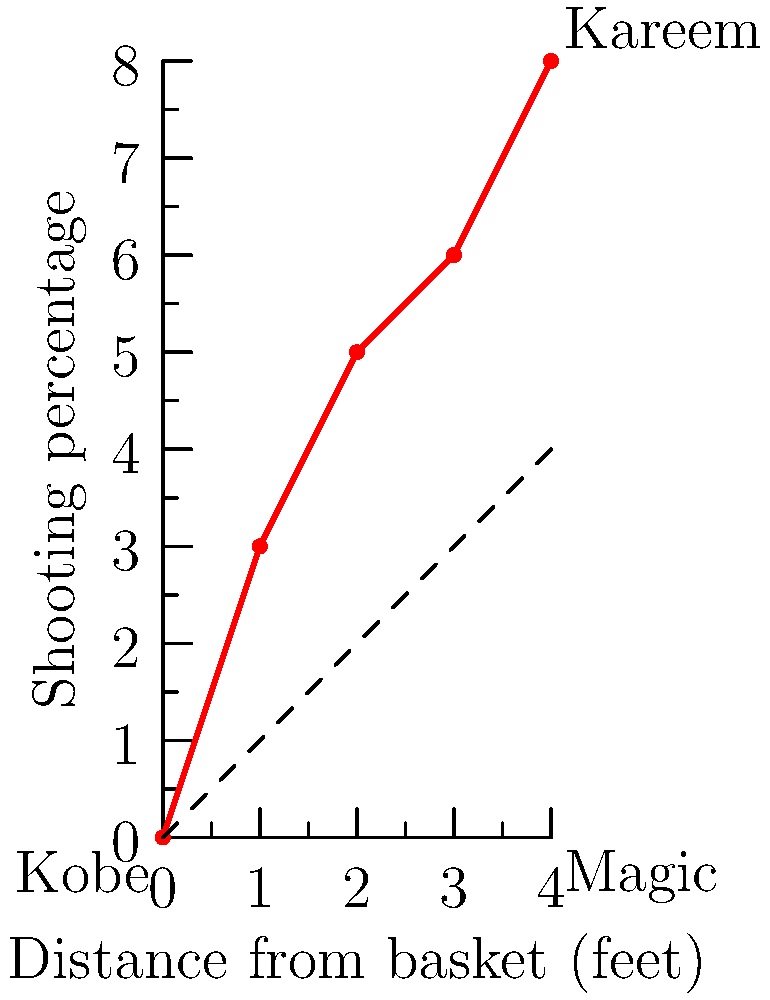In the graph showing the shooting percentages of Lakers legends at different distances from the basket, Kobe's data points are represented by the red line. If we were to scale Kobe's vector by a factor of 1.5 to represent Kareem Abdul-Jabbar's shooting percentages, what would be Kareem's shooting percentage at 4 feet from the basket? To solve this problem, we need to follow these steps:

1. Identify Kobe's shooting percentage at 4 feet from the basket:
   From the graph, we can see that at x = 4, y ≈ 8

2. Apply the scaling factor to Kobe's vector:
   Kareem's vector = 1.5 × Kobe's vector
   
3. Calculate Kareem's shooting percentage:
   Kareem's percentage = 1.5 × Kobe's percentage
   Kareem's percentage = 1.5 × 8 = 12

4. Verify the result:
   The scaled vector for Kareem should end at the point (4, 12), which is consistent with the graph showing Kareem's data points at the top right.

Therefore, Kareem Abdul-Jabbar's shooting percentage at 4 feet from the basket would be 12%.
Answer: 12% 